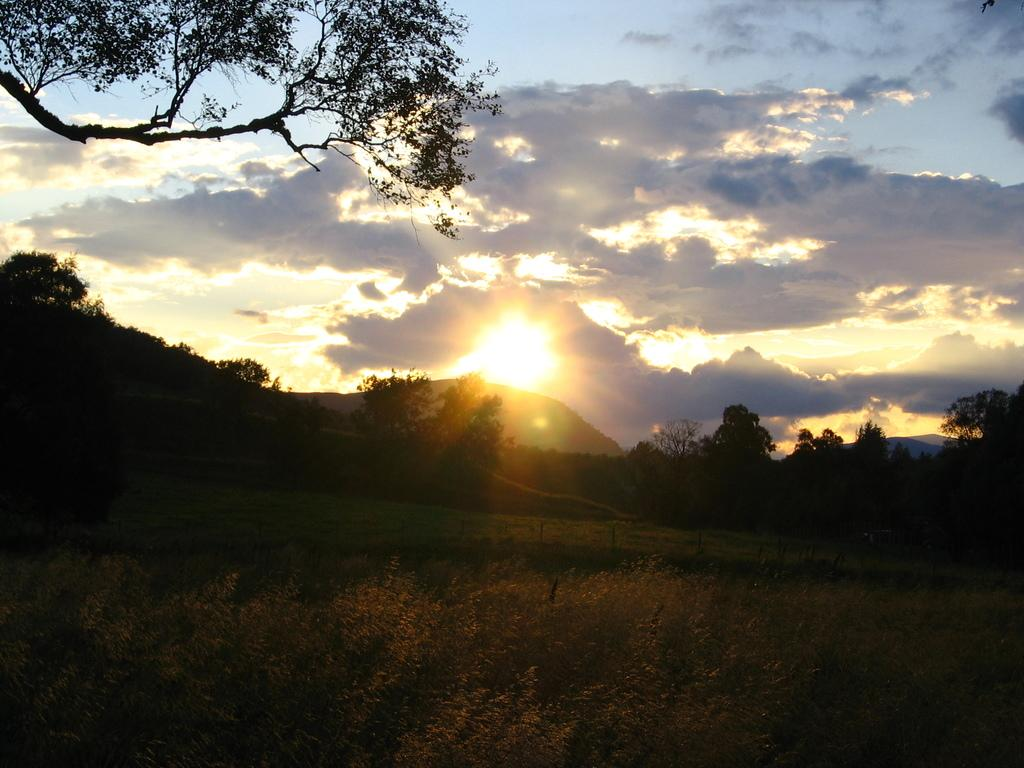What type of vegetation can be seen in the image? There are plants and trees in the image. What type of landscape is visible in the image? There are mountains in the image. What type of ground cover is present in the image? There is grass in the image. What can be seen in the background of the image? The sun and sky are visible in the background of the image, with clouds present. Where is the stage located in the image? There is no stage present in the image. How many deer can be seen in the image? There are no deer present in the image. 